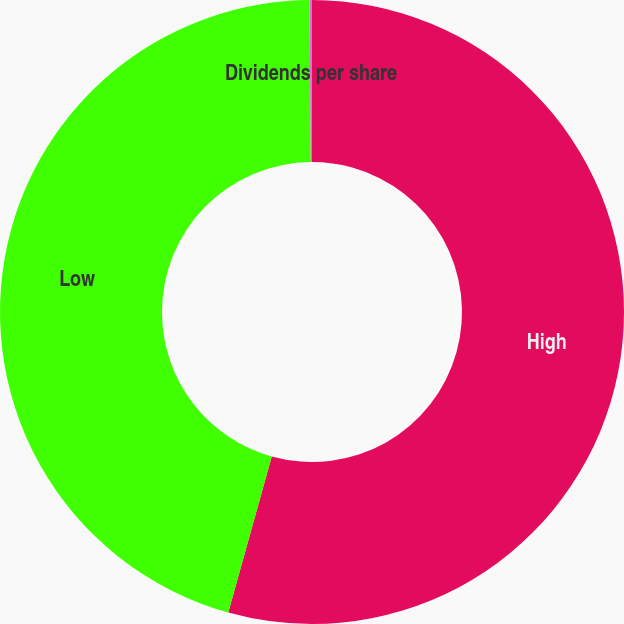Convert chart to OTSL. <chart><loc_0><loc_0><loc_500><loc_500><pie_chart><fcel>High<fcel>Low<fcel>Dividends per share<nl><fcel>54.33%<fcel>45.55%<fcel>0.13%<nl></chart> 